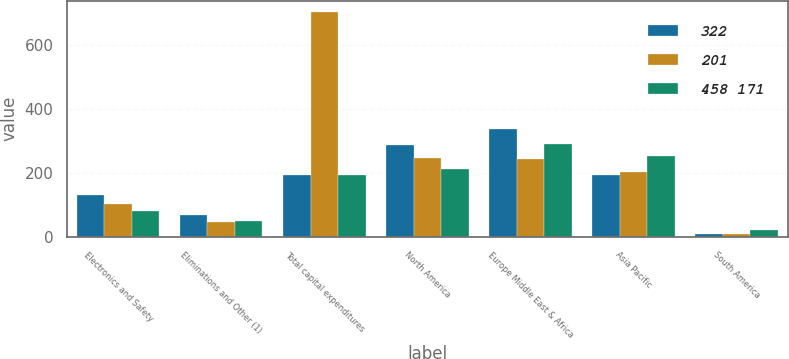Convert chart. <chart><loc_0><loc_0><loc_500><loc_500><stacked_bar_chart><ecel><fcel>Electronics and Safety<fcel>Eliminations and Other (1)<fcel>Total capital expenditures<fcel>North America<fcel>Europe Middle East & Africa<fcel>Asia Pacific<fcel>South America<nl><fcel>322<fcel>131<fcel>68<fcel>193<fcel>288<fcel>338<fcel>193<fcel>9<nl><fcel>201<fcel>102<fcel>48<fcel>704<fcel>247<fcel>245<fcel>202<fcel>10<nl><fcel>458 171<fcel>82<fcel>49<fcel>193<fcel>214<fcel>290<fcel>253<fcel>22<nl></chart> 